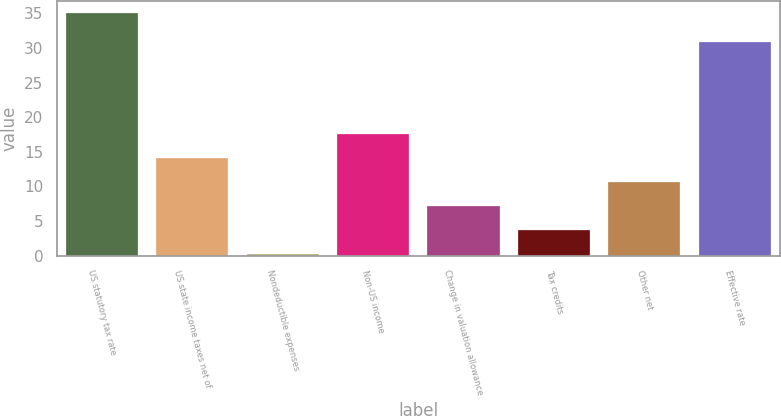<chart> <loc_0><loc_0><loc_500><loc_500><bar_chart><fcel>US statutory tax rate<fcel>US state income taxes net of<fcel>Nondeductible expenses<fcel>Non-US income<fcel>Change in valuation allowance<fcel>Tax credits<fcel>Other net<fcel>Effective rate<nl><fcel>35<fcel>14.12<fcel>0.2<fcel>17.6<fcel>7.16<fcel>3.68<fcel>10.64<fcel>30.8<nl></chart> 